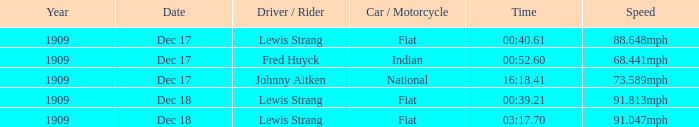Which driver has indian nationality? Fred Huyck. 